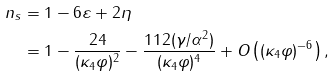Convert formula to latex. <formula><loc_0><loc_0><loc_500><loc_500>n _ { s } & = 1 - 6 \varepsilon + 2 \eta \\ & = 1 - \frac { 2 4 } { ( \kappa _ { 4 } \varphi ) ^ { 2 } } - \frac { 1 1 2 ( \gamma / \alpha ^ { 2 } ) } { ( \kappa _ { 4 } \varphi ) ^ { 4 } } + O \left ( ( \kappa _ { 4 } \varphi ) ^ { - 6 } \right ) ,</formula> 